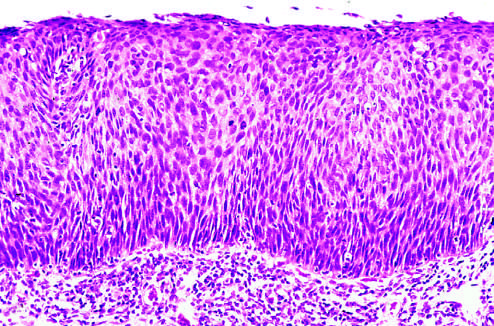what is the entire thickness of the epithelium replaced by?
Answer the question using a single word or phrase. Atypical dysplastic cells 